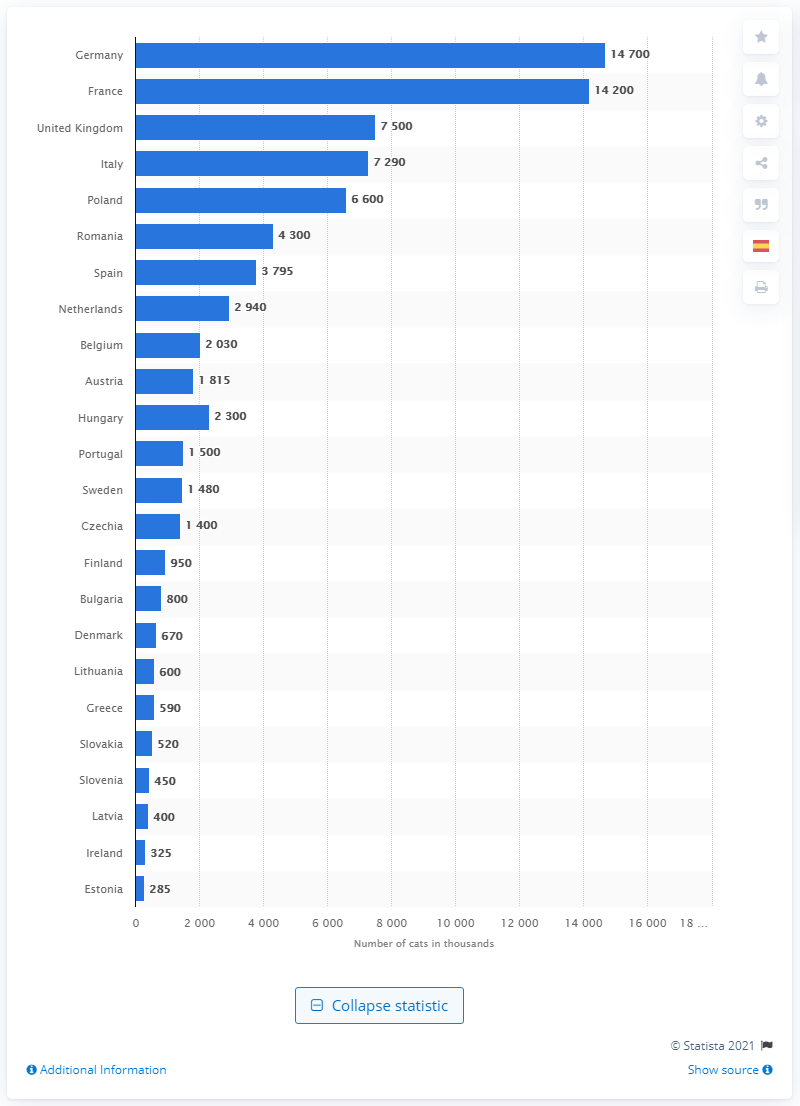List a handful of essential elements in this visual. According to the EU, Germany is the country with the highest number of pet dogs, making it the top EU country in this regard. 